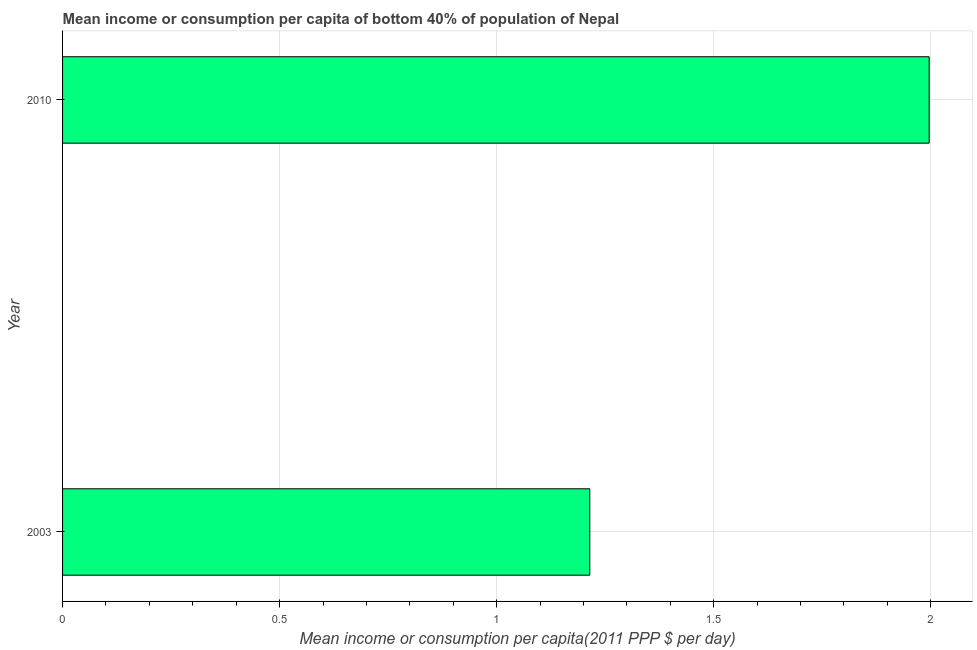Does the graph contain any zero values?
Give a very brief answer. No. Does the graph contain grids?
Keep it short and to the point. Yes. What is the title of the graph?
Your answer should be very brief. Mean income or consumption per capita of bottom 40% of population of Nepal. What is the label or title of the X-axis?
Provide a succinct answer. Mean income or consumption per capita(2011 PPP $ per day). What is the mean income or consumption in 2010?
Offer a terse response. 2. Across all years, what is the maximum mean income or consumption?
Offer a very short reply. 2. Across all years, what is the minimum mean income or consumption?
Provide a succinct answer. 1.21. In which year was the mean income or consumption maximum?
Your answer should be compact. 2010. In which year was the mean income or consumption minimum?
Make the answer very short. 2003. What is the sum of the mean income or consumption?
Make the answer very short. 3.21. What is the difference between the mean income or consumption in 2003 and 2010?
Provide a succinct answer. -0.78. What is the average mean income or consumption per year?
Give a very brief answer. 1.61. What is the median mean income or consumption?
Ensure brevity in your answer.  1.61. In how many years, is the mean income or consumption greater than 0.7 $?
Keep it short and to the point. 2. What is the ratio of the mean income or consumption in 2003 to that in 2010?
Offer a terse response. 0.61. How many bars are there?
Your answer should be compact. 2. Are all the bars in the graph horizontal?
Your answer should be very brief. Yes. How many years are there in the graph?
Offer a terse response. 2. What is the difference between two consecutive major ticks on the X-axis?
Your response must be concise. 0.5. What is the Mean income or consumption per capita(2011 PPP $ per day) of 2003?
Offer a terse response. 1.21. What is the Mean income or consumption per capita(2011 PPP $ per day) in 2010?
Give a very brief answer. 2. What is the difference between the Mean income or consumption per capita(2011 PPP $ per day) in 2003 and 2010?
Keep it short and to the point. -0.78. What is the ratio of the Mean income or consumption per capita(2011 PPP $ per day) in 2003 to that in 2010?
Provide a short and direct response. 0.61. 